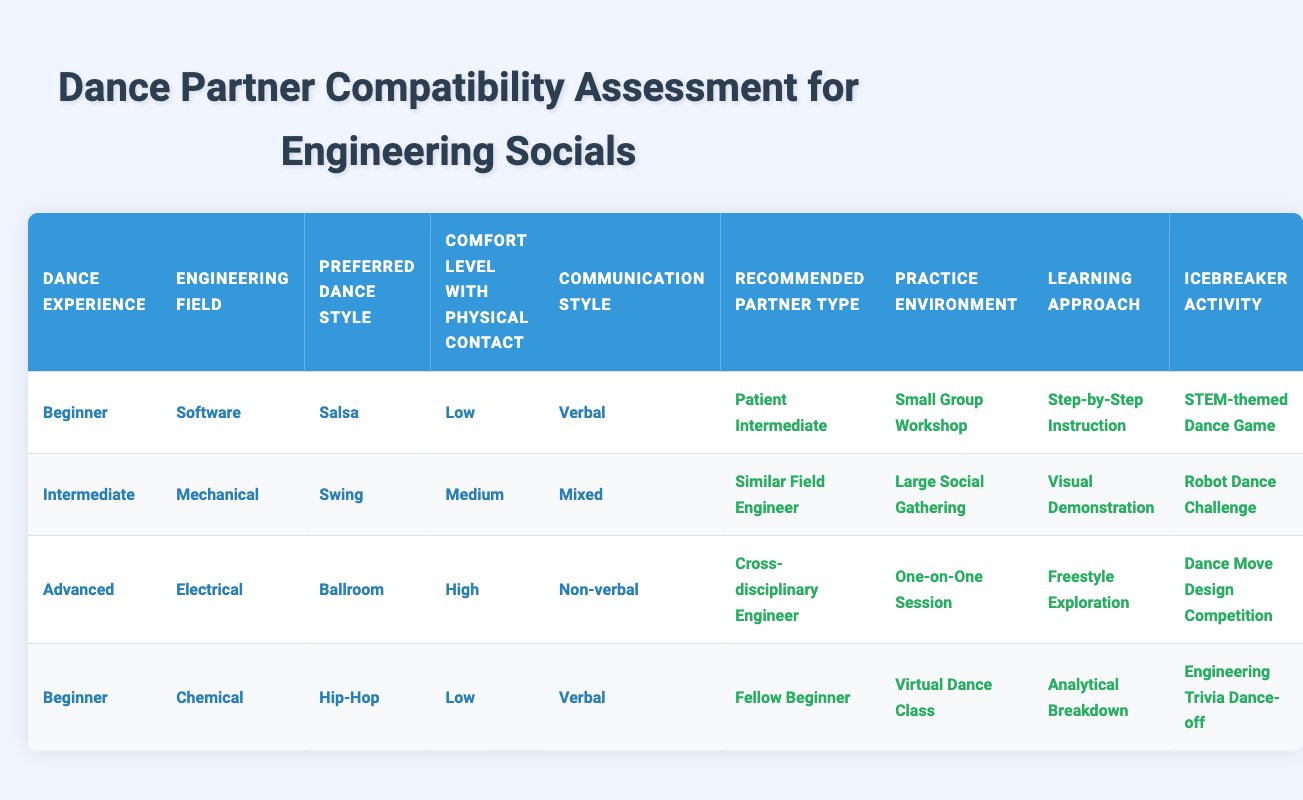What is the recommended partner type for a beginner in the software engineering field who prefers salsa? The table shows that for a "Beginner" in the "Software" field with a "Preferred Dance Style" of "Salsa," the recommended partner type is "Patient Intermediate." This can be directly retrieved from the first row of the table.
Answer: Patient Intermediate What practice environment is suggested for an intermediate mechanical engineer who enjoys swing dance? According to the second row of the table, for an "Intermediate" in "Mechanical" engineering who prefers "Swing," the recommended "Practice Environment" is a "Large Social Gathering." This information can be found directly in that row.
Answer: Large Social Gathering Is it true that advanced dancers in the electrical field who prefer ballroom dance have a high comfort level with physical contact? In the third row of the table, it indicates that "Advanced" dancers in the "Electrical" field who prefer "Ballroom" do indeed have a "High" comfort level with physical contact. Therefore, the answer to this question is yes.
Answer: Yes What is the preferred dance style for the fellow beginner partner type? Looking at the fourth row of the table, it states that for a "Fellow Beginner," the "Preferred Dance Style" is "Hip-Hop." This can be checked specifically in that row.
Answer: Hip-Hop What learning approach is suggested for a beginner chemical engineer who has a low comfort level with physical contact? From the fourth row of the table, it can be seen that for a "Beginner" in "Chemical" engineering with a "Low" comfort level, the "Learning Approach" is "Analytical Breakdown." This matches the criteria directly.
Answer: Analytical Breakdown What is the average comfort level among the mentioned conditions in the table? The conditions listed in the table describe "Low," "Medium," and "High" levels of comfort. To find the average, we can assign values: Low = 1, Medium = 2, High = 3. The levels represented are Low (1), Medium (2), Low (1), High (3) totaling 7, divided by 4 gives an average of 1.75, which corresponds to a comfort level slightly above low but below medium.
Answer: 1.75 What is the icebreaker activity recommended for an advanced dancer in the electrical field? According to the third row of the table, the recommended "Icebreaker Activity" for someone who is "Advanced," in the "Electrical" field, and prefers "Ballroom" dance, is the "Dance Move Design Competition." This is clearly indicated in that row.
Answer: Dance Move Design Competition Which type of dance partner would a beginner in the chemical field ideally have? In the fourth row, it specifies that a "Beginner" in the "Chemical" field would ideally have a "Fellow Beginner" as their partner. This is extracted directly from the conditions of that row.
Answer: Fellow Beginner 